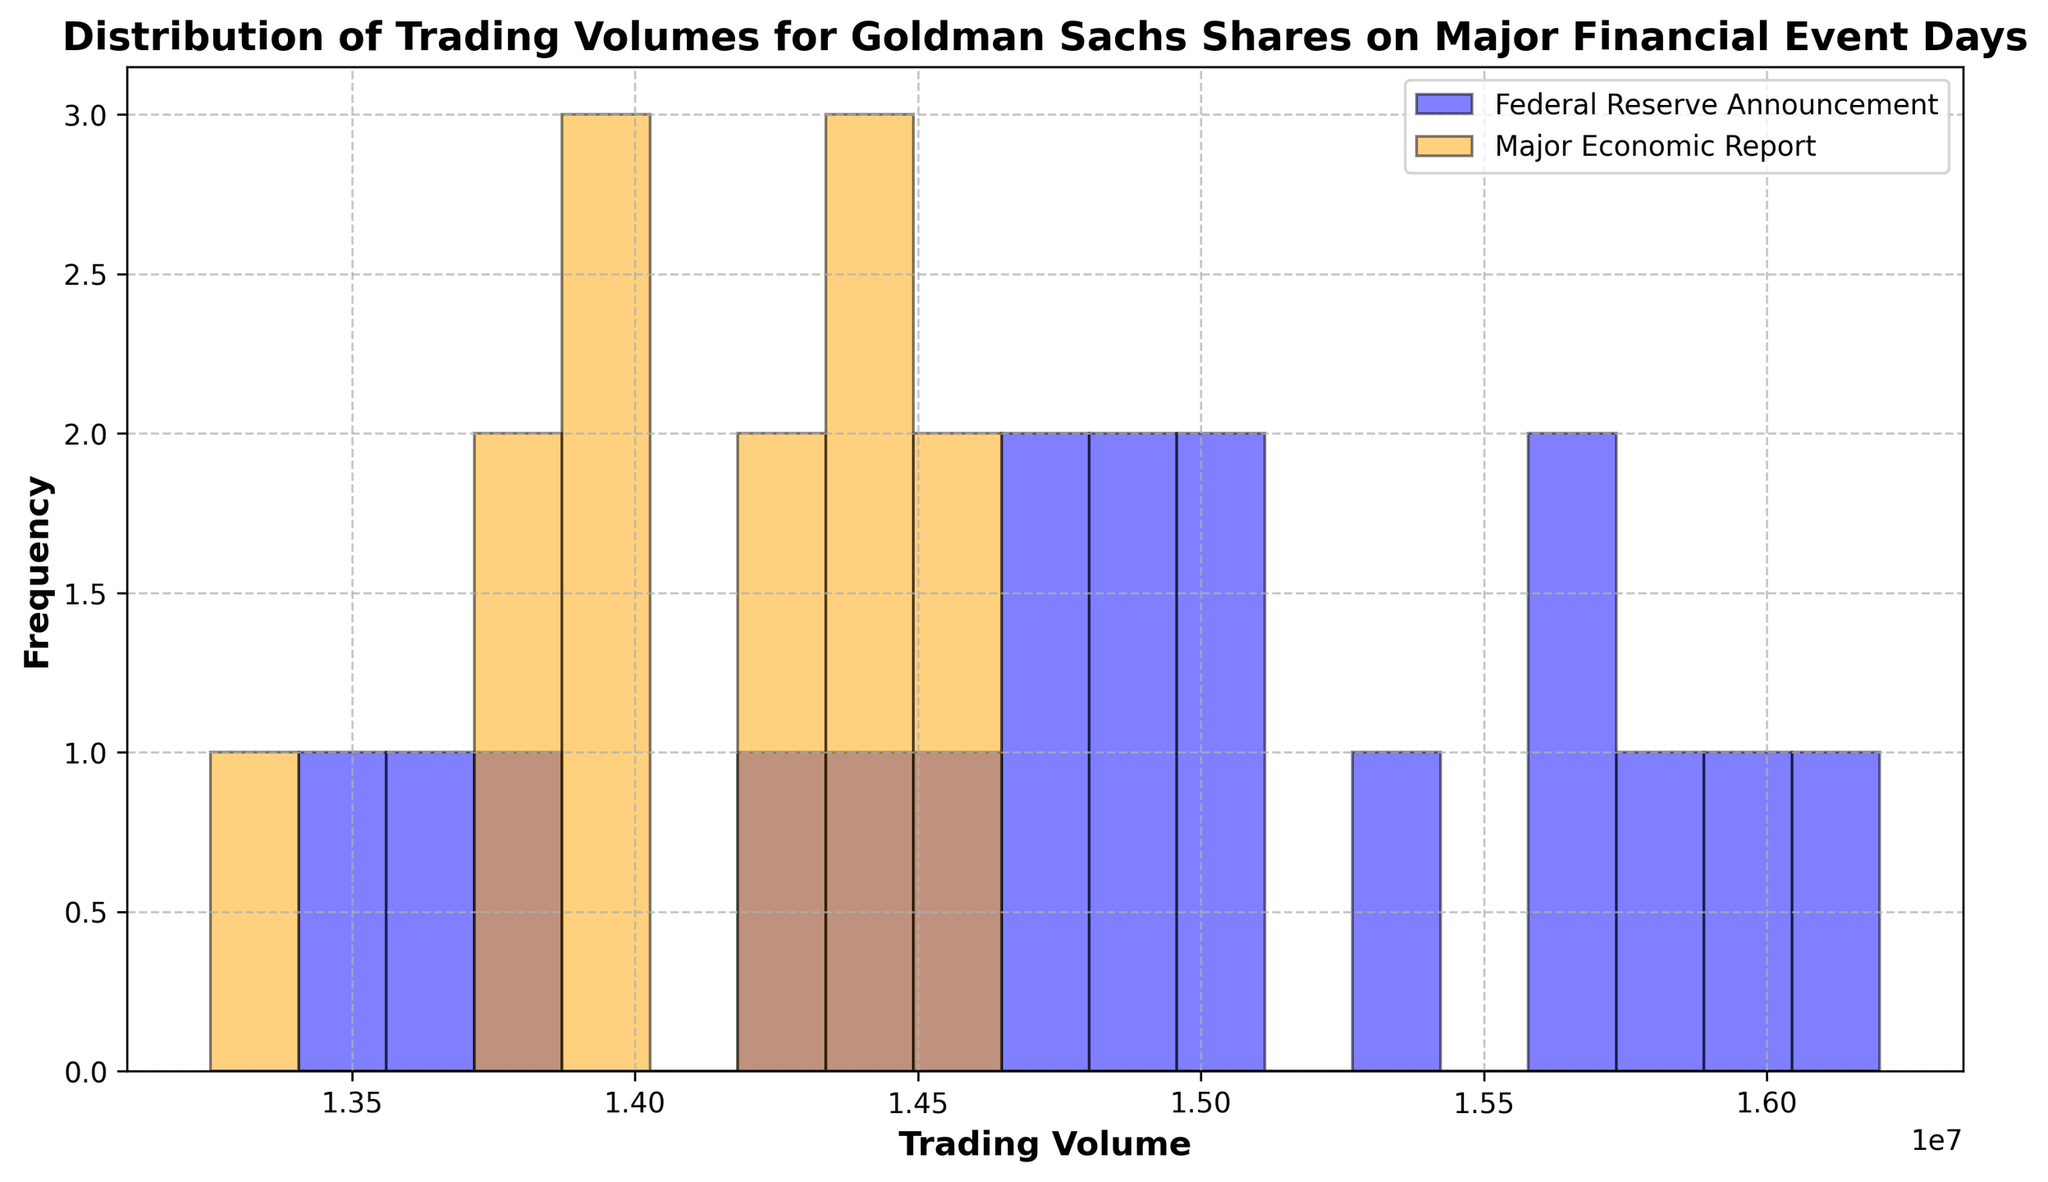Which event type has the highest frequency of trading volumes in the histogram? Observe the height of the bars in the histogram. The bars representing 'Federal Reserve Announcements' appear taller indicating a higher frequency.
Answer: Federal Reserve Announcement Which event type generally has higher trading volumes, Federal Reserve Announcements or Major Economic Reports? Compare the positions of the bars on the horizontal axis. The bars of 'Federal Reserve Announcements' are generally positioned further to the right indicating higher trading volumes.
Answer: Federal Reserve Announcements Are there more days with trading volumes between 14,000,000 and 16,000,000 during Federal Reserve Announcements or Major Economic Reports? Count the number of bars within the specified range for both event types. 'Federal Reserve Announcements' have more bars within this range than 'Major Economic Reports'.
Answer: Federal Reserve Announcements What is the most common trading volume range for Major Economic Reports? Look at where the highest bars for 'Major Economic Reports' are located on the horizontal axis. The highest frequency appears around the 14,500,000 range.
Answer: Around 14,500,000 Do Federal Reserve Announcements have a more varied distribution of trading volumes compared to Major Economic Reports? Observe the spread of the bars for both categories. The bars for 'Federal Reserve Announcements' cover a wider range, indicating a more varied distribution.
Answer: Yes What's the approximate trading volume range for days with the highest frequency of Federal Reserve Announcements? Identify the highest bars in the 'Federal Reserve Announcements' series and note their position on the horizontal axis. The peak frequency is around the 15,000,000 to 15,500,000 range.
Answer: 15,000,000 to 15,500,000 Between 15,000,000 and 16,000,000 trading volumes, which event type contributes more to this range? Compare the number of bars and their height within this range for both event types. 'Federal Reserve Announcements' have more bars and taller bars within this range.
Answer: Federal Reserve Announcements Which event type has the least trading volume range covered in the histogram? Observe which event type has fewer bars spread across the horizontal axis. 'Major Economic Reports' have bars in a more limited range compared to 'Federal Reserve Announcements'.
Answer: Major Economic Reports 